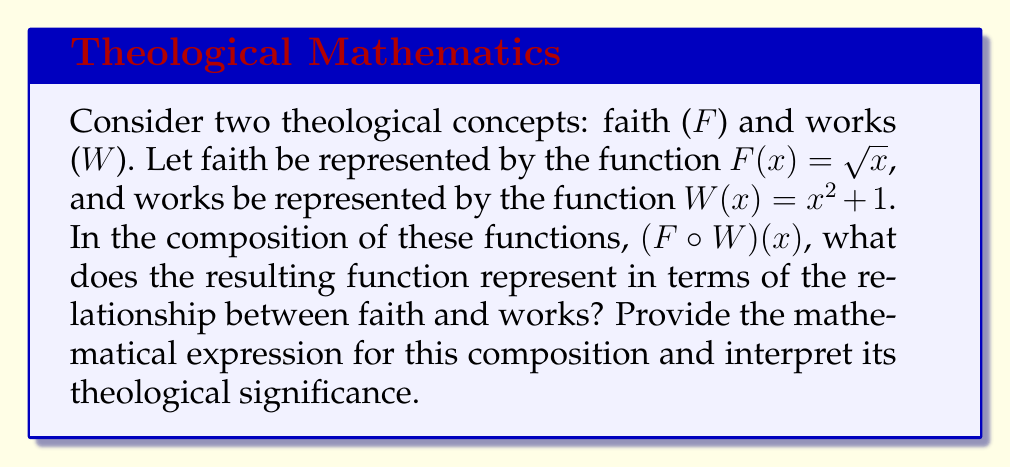Show me your answer to this math problem. To solve this problem, we need to follow these steps:

1) First, we need to understand what composition of functions means. For $(F \circ W)(x)$, we apply W first, then F.

2) Let's compose the functions:
   $(F \circ W)(x) = F(W(x))$
   $= F(x^2 + 1)$
   $= \sqrt{x^2 + 1}$

3) Now, let's interpret this theologically:

   - The inner function $W(x) = x^2 + 1$ represents works. The squaring suggests that works compound, and the +1 could represent that even without works, there's a baseline of existence.
   
   - The outer function $F(x) = \sqrt{x}$ represents faith. The square root suggests that faith grows more slowly than works, but is essential in transforming works.
   
   - The composition $\sqrt{x^2 + 1}$ suggests that faith operates on works, transforming them. However, the +1 inside the square root ensures that the result is always defined and positive, even when x (representing initial works) is zero.

4) Theologically, this could be interpreted as:
   - Faith and works are interconnected.
   - Faith transforms works, but even without works, faith ensures a positive outcome.
   - The growth of this combined function is more moderate than works alone, suggesting that faith tempers and gives meaning to works.
   - The function is always defined and positive, suggesting that the combination of faith and works always yields a meaningful result in one's spiritual life.

This mathematical model aligns with the biblical teaching that faith and works are interconnected (James 2:14-26), while also maintaining the primacy of faith (Ephesians 2:8-9).
Answer: $(F \circ W)(x) = \sqrt{x^2 + 1}$

This function represents the interconnectedness of faith and works, where faith (represented by the square root) acts upon and transforms works (represented by the quadratic function), resulting in a spiritually meaningful outcome that is always positive and defined. 